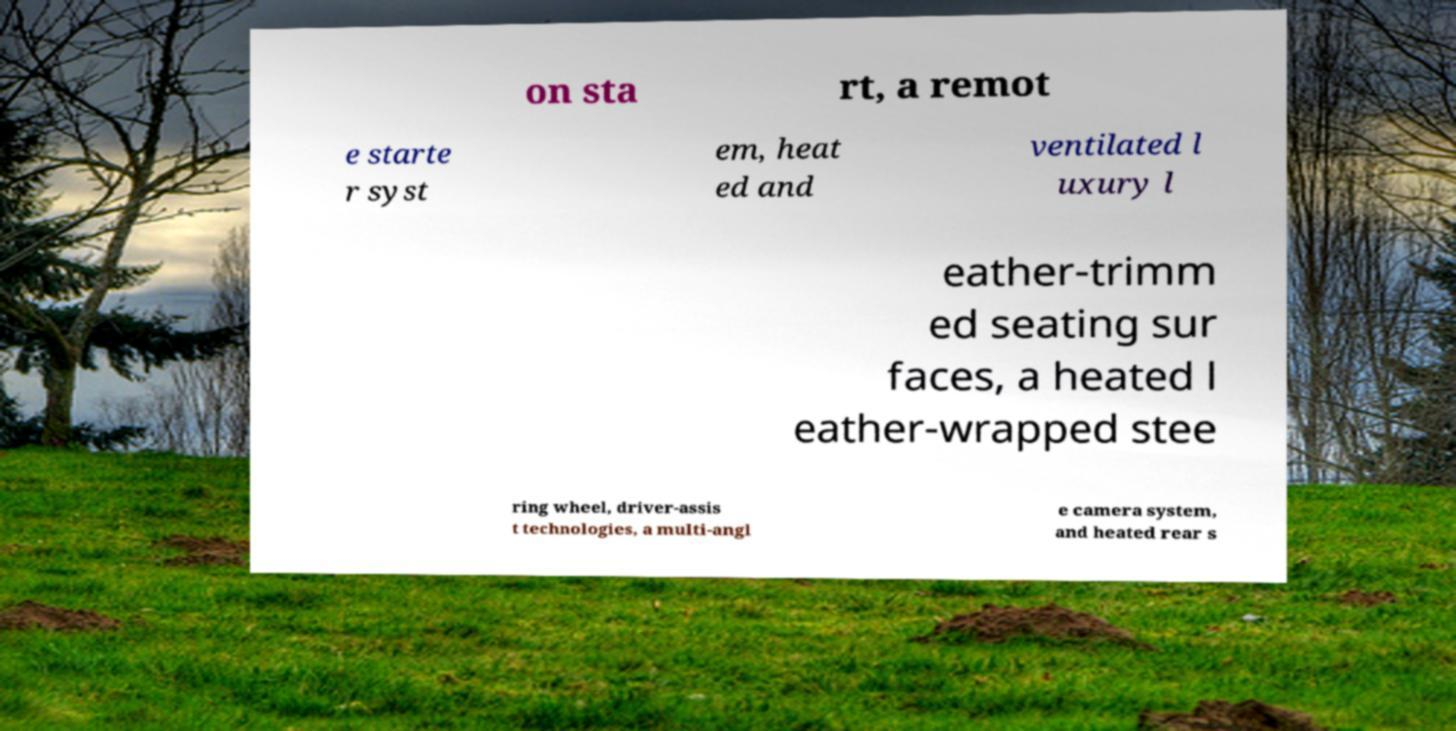There's text embedded in this image that I need extracted. Can you transcribe it verbatim? on sta rt, a remot e starte r syst em, heat ed and ventilated l uxury l eather-trimm ed seating sur faces, a heated l eather-wrapped stee ring wheel, driver-assis t technologies, a multi-angl e camera system, and heated rear s 